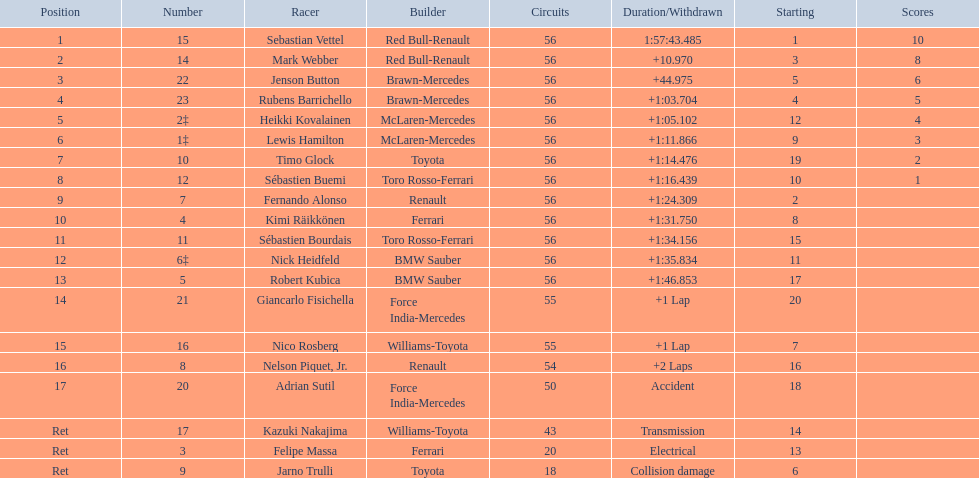Who were all the drivers? Sebastian Vettel, Mark Webber, Jenson Button, Rubens Barrichello, Heikki Kovalainen, Lewis Hamilton, Timo Glock, Sébastien Buemi, Fernando Alonso, Kimi Räikkönen, Sébastien Bourdais, Nick Heidfeld, Robert Kubica, Giancarlo Fisichella, Nico Rosberg, Nelson Piquet, Jr., Adrian Sutil, Kazuki Nakajima, Felipe Massa, Jarno Trulli. Which of these didn't have ferrari as a constructor? Sebastian Vettel, Mark Webber, Jenson Button, Rubens Barrichello, Heikki Kovalainen, Lewis Hamilton, Timo Glock, Sébastien Buemi, Fernando Alonso, Sébastien Bourdais, Nick Heidfeld, Robert Kubica, Giancarlo Fisichella, Nico Rosberg, Nelson Piquet, Jr., Adrian Sutil, Kazuki Nakajima, Jarno Trulli. Which of these was in first place? Sebastian Vettel. Parse the full table. {'header': ['Position', 'Number', 'Racer', 'Builder', 'Circuits', 'Duration/Withdrawn', 'Starting', 'Scores'], 'rows': [['1', '15', 'Sebastian Vettel', 'Red Bull-Renault', '56', '1:57:43.485', '1', '10'], ['2', '14', 'Mark Webber', 'Red Bull-Renault', '56', '+10.970', '3', '8'], ['3', '22', 'Jenson Button', 'Brawn-Mercedes', '56', '+44.975', '5', '6'], ['4', '23', 'Rubens Barrichello', 'Brawn-Mercedes', '56', '+1:03.704', '4', '5'], ['5', '2‡', 'Heikki Kovalainen', 'McLaren-Mercedes', '56', '+1:05.102', '12', '4'], ['6', '1‡', 'Lewis Hamilton', 'McLaren-Mercedes', '56', '+1:11.866', '9', '3'], ['7', '10', 'Timo Glock', 'Toyota', '56', '+1:14.476', '19', '2'], ['8', '12', 'Sébastien Buemi', 'Toro Rosso-Ferrari', '56', '+1:16.439', '10', '1'], ['9', '7', 'Fernando Alonso', 'Renault', '56', '+1:24.309', '2', ''], ['10', '4', 'Kimi Räikkönen', 'Ferrari', '56', '+1:31.750', '8', ''], ['11', '11', 'Sébastien Bourdais', 'Toro Rosso-Ferrari', '56', '+1:34.156', '15', ''], ['12', '6‡', 'Nick Heidfeld', 'BMW Sauber', '56', '+1:35.834', '11', ''], ['13', '5', 'Robert Kubica', 'BMW Sauber', '56', '+1:46.853', '17', ''], ['14', '21', 'Giancarlo Fisichella', 'Force India-Mercedes', '55', '+1 Lap', '20', ''], ['15', '16', 'Nico Rosberg', 'Williams-Toyota', '55', '+1 Lap', '7', ''], ['16', '8', 'Nelson Piquet, Jr.', 'Renault', '54', '+2 Laps', '16', ''], ['17', '20', 'Adrian Sutil', 'Force India-Mercedes', '50', 'Accident', '18', ''], ['Ret', '17', 'Kazuki Nakajima', 'Williams-Toyota', '43', 'Transmission', '14', ''], ['Ret', '3', 'Felipe Massa', 'Ferrari', '20', 'Electrical', '13', ''], ['Ret', '9', 'Jarno Trulli', 'Toyota', '18', 'Collision damage', '6', '']]} 